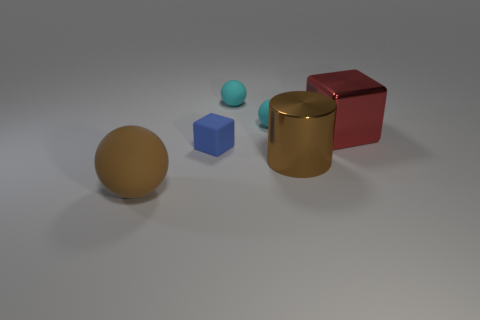Is there a red cube? Yes, there is a red cube prominently displayed in the center-right of the image, alongside other geometric shapes like a gold cylinder and a blue cube. 